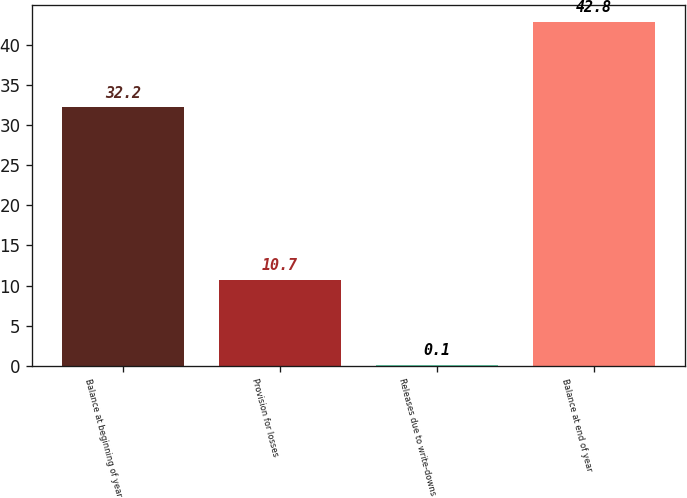<chart> <loc_0><loc_0><loc_500><loc_500><bar_chart><fcel>Balance at beginning of year<fcel>Provision for losses<fcel>Releases due to write-downs<fcel>Balance at end of year<nl><fcel>32.2<fcel>10.7<fcel>0.1<fcel>42.8<nl></chart> 